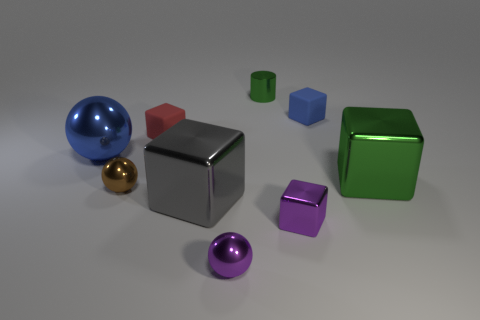Do the objects imply a particular setting or context? The image doesn't directly suggest a specific setting due to its neutral background and the generic nature of the objects. However, the objects' simple geometric forms and reflective surfaces may evoke a minimalist or design-oriented environment, potentially the result of a computer-generated rendering used in product visualization or graphic design projects. 